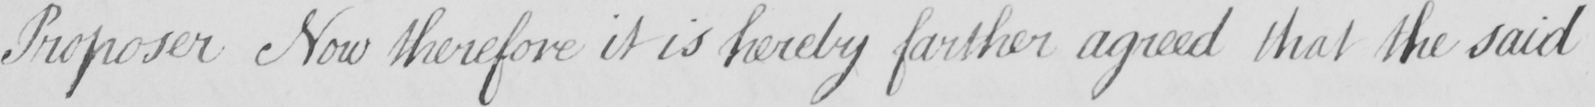What is written in this line of handwriting? Proposer Now therefore it is hereby farther agreed that the said 